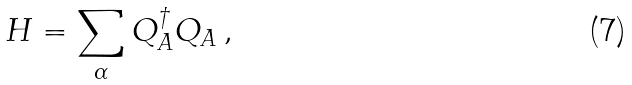<formula> <loc_0><loc_0><loc_500><loc_500>H = \sum _ { \alpha } Q ^ { \dagger } _ { A } Q _ { A } \, ,</formula> 